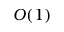Convert formula to latex. <formula><loc_0><loc_0><loc_500><loc_500>O ( 1 )</formula> 